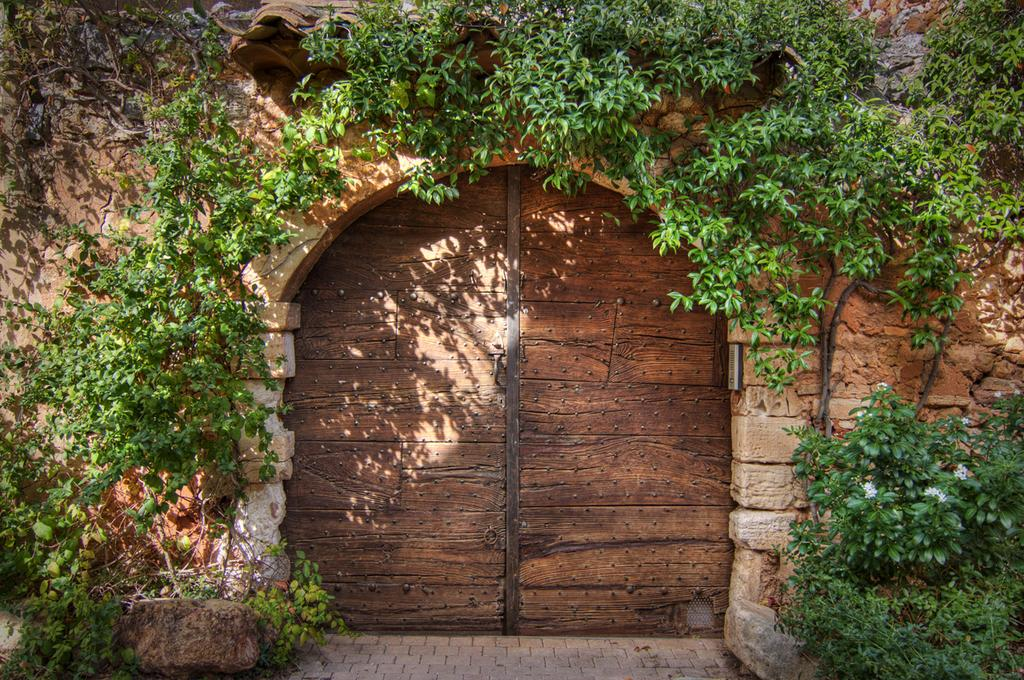What type of living organisms can be seen in the image? There are many plants in the image. What type of material is the door made of in the image? The door in the image is made of wood. What is the background of the image made of? There is a wall in the image. What surface is visible beneath the plants in the image? There is a floor visible in the image. What type of birds can be seen flying in the image? There are no birds visible in the image. Who is the representative of the plants in the image? The image does not depict a representative for the plants. 